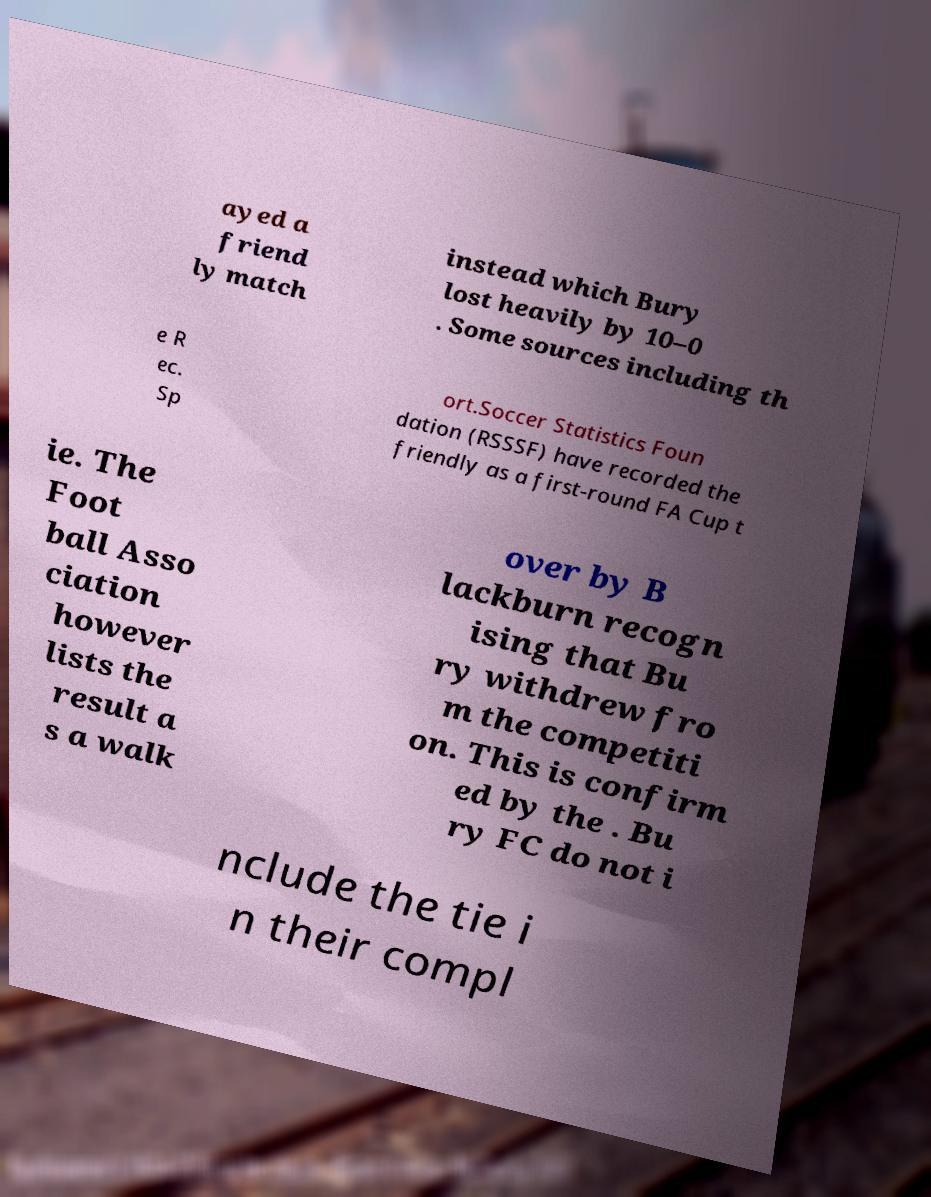There's text embedded in this image that I need extracted. Can you transcribe it verbatim? ayed a friend ly match instead which Bury lost heavily by 10–0 . Some sources including th e R ec. Sp ort.Soccer Statistics Foun dation (RSSSF) have recorded the friendly as a first-round FA Cup t ie. The Foot ball Asso ciation however lists the result a s a walk over by B lackburn recogn ising that Bu ry withdrew fro m the competiti on. This is confirm ed by the . Bu ry FC do not i nclude the tie i n their compl 